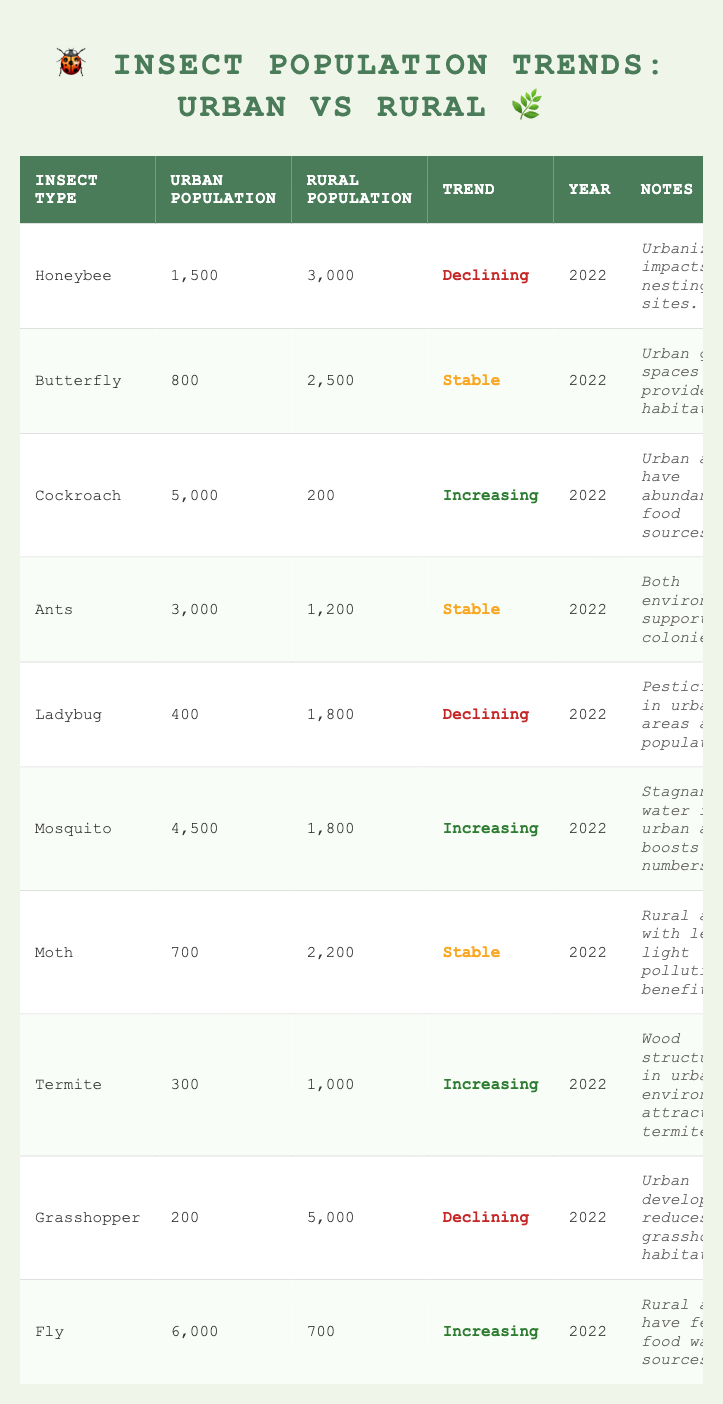What is the urban population of the Honeybee? The table lists the urban population of the Honeybee, which is shown in the corresponding row under the "Urban Population" column. The number given for Honeybee is 1,500.
Answer: 1,500 How many insects had a stable population trend in urban areas? To find the number of insects with a stable population trend, we look at the "Trend" column and count the entries that say "Stable." There are three such entries: Butterfly, Ant, and Moth.
Answer: 3 What is the total rural population of Cockroaches and Flies combined? To find the total rural population, we add the rural populations of Cockroaches (200) and Flies (700). The sum is 200 + 700 = 900.
Answer: 900 Is the Mosquito population increasing in urban areas? We can check the trend for Mosquito from the table. The trend indicates that the Mosquito population in urban areas is increasing, as stated in the corresponding row.
Answer: Yes What is the difference in urban populations between Cockroaches and Ladybugs? First, look at the urban populations: Cockroaches have 5,000 and Ladybugs have 400. Now, calculate the difference: 5,000 - 400 = 4,600.
Answer: 4,600 Which insect has the highest urban population, and what is that number? By scanning the "Urban Population" column, we identify that Cockroaches have the highest population at 5,000. This is the largest number listed in the urban populations.
Answer: Cockroach, 5,000 Are there more insects in rural areas than urban areas overall? To determine this, we sum the rural populations and the urban populations separately. The rural total is 3,000 + 2,500 + 200 + 1,200 + 1,800 + 1,800 + 2,200 + 1,000 + 5,000 + 700 = 19,200. The urban total is 1,500 + 800 + 5,000 + 3,000 + 400 + 4,500 + 700 + 300 + 200 + 6,000 = 22,500. Since 19,200 < 22,500, rural areas do not have more insects.
Answer: No How many types of insects are increasing in both urban and rural populations? We look for insects with an "Increasing" trend in both urban and rural areas. Cockroaches are increasing in urban but not in rural; Mosquitos are increasing in urban but stable in rural; Termites are increasing in urban and rural both. Thus, only Termites qualify.
Answer: 1 What insect has the highest rural population, and what is that figure? We find the maximum value in the "Rural Population" column. The largest number is for Grasshopper at 5,000.
Answer: Grasshopper, 5,000 